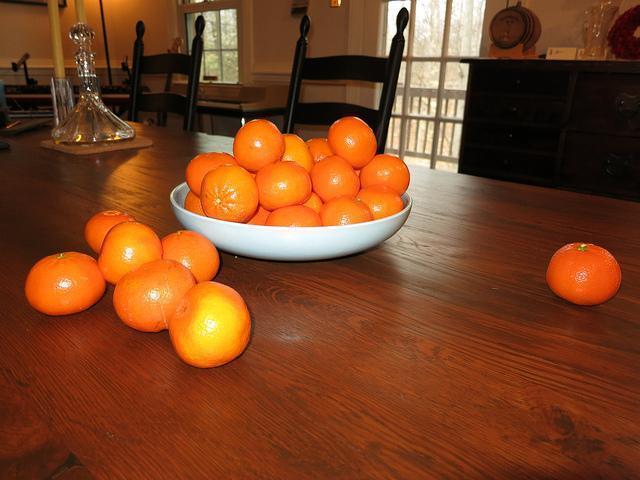How many oranges have mold?
Give a very brief answer. 0. How many chairs are there?
Give a very brief answer. 2. How many oranges are there?
Give a very brief answer. 6. How many bowls are there?
Give a very brief answer. 1. 